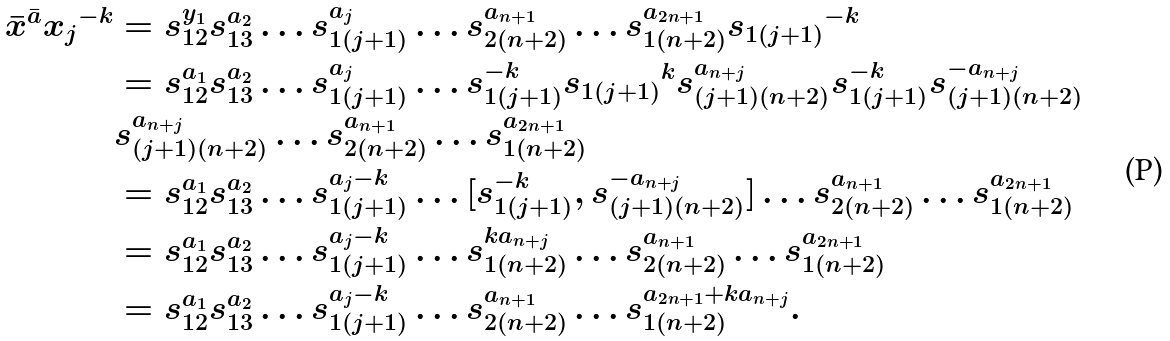Convert formula to latex. <formula><loc_0><loc_0><loc_500><loc_500>\bar { x } ^ { \bar { a } } { x _ { j } } ^ { - k } & = s _ { 1 2 } ^ { y _ { 1 } } s _ { 1 3 } ^ { a _ { 2 } } \dots s _ { 1 ( j + 1 ) } ^ { a _ { j } } \dots s _ { 2 ( n + 2 ) } ^ { a _ { n + 1 } } \dots s _ { 1 ( n + 2 ) } ^ { a _ { 2 n + 1 } } { s _ { 1 ( j + 1 ) } } ^ { - k } \\ & = s _ { 1 2 } ^ { a _ { 1 } } s _ { 1 3 } ^ { a _ { 2 } } \dots s _ { 1 ( j + 1 ) } ^ { a _ { j } } \dots s _ { 1 ( j + 1 ) } ^ { - k } { s _ { 1 ( j + 1 ) } } ^ { k } s _ { ( j + 1 ) ( n + 2 ) } ^ { a _ { n + j } } s _ { 1 ( j + 1 ) } ^ { - k } s _ { ( j + 1 ) ( n + 2 ) } ^ { - a _ { n + j } } \\ & s _ { ( j + 1 ) ( n + 2 ) } ^ { a _ { n + j } } \dots s _ { 2 ( n + 2 ) } ^ { a _ { n + 1 } } \dots s _ { 1 ( n + 2 ) } ^ { a _ { 2 n + 1 } } \\ & = s _ { 1 2 } ^ { a _ { 1 } } s _ { 1 3 } ^ { a _ { 2 } } \dots s _ { 1 ( j + 1 ) } ^ { a _ { j } - k } \dots [ s _ { 1 ( j + 1 ) } ^ { - k } , s _ { ( j + 1 ) ( n + 2 ) } ^ { - a _ { n + j } } ] \dots s _ { 2 ( n + 2 ) } ^ { a _ { n + 1 } } \dots s _ { 1 ( n + 2 ) } ^ { a _ { 2 n + 1 } } \\ & = s _ { 1 2 } ^ { a _ { 1 } } s _ { 1 3 } ^ { a _ { 2 } } \dots s _ { 1 ( j + 1 ) } ^ { a _ { j } - k } \dots s _ { 1 ( n + 2 ) } ^ { k a _ { n + j } } \dots s _ { 2 ( n + 2 ) } ^ { a _ { n + 1 } } \dots s _ { 1 ( n + 2 ) } ^ { a _ { 2 n + 1 } } \\ & = s _ { 1 2 } ^ { a _ { 1 } } s _ { 1 3 } ^ { a _ { 2 } } \dots s _ { 1 ( j + 1 ) } ^ { a _ { j } - k } \dots s _ { 2 ( n + 2 ) } ^ { a _ { n + 1 } } \dots s _ { 1 ( n + 2 ) } ^ { a _ { 2 n + 1 } + k a _ { n + j } } .</formula> 